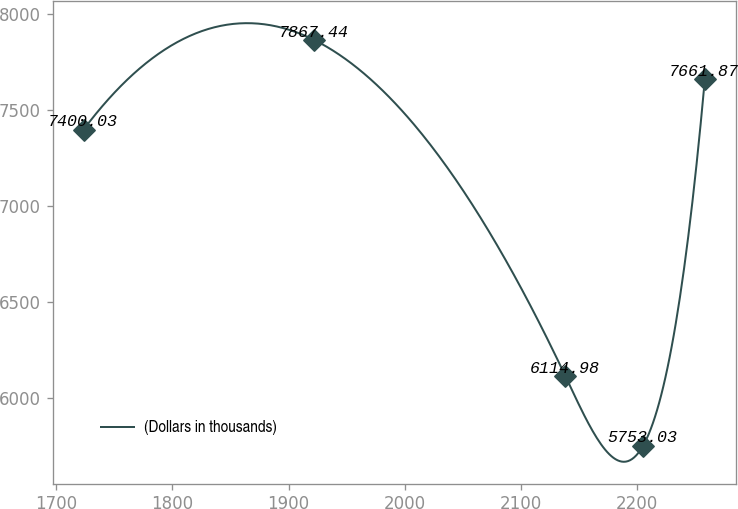Convert chart to OTSL. <chart><loc_0><loc_0><loc_500><loc_500><line_chart><ecel><fcel>(Dollars in thousands)<nl><fcel>1723.67<fcel>7400.03<nl><fcel>1921.87<fcel>7867.44<nl><fcel>2138.13<fcel>6114.98<nl><fcel>2205.05<fcel>5753.03<nl><fcel>2258.11<fcel>7661.87<nl></chart> 